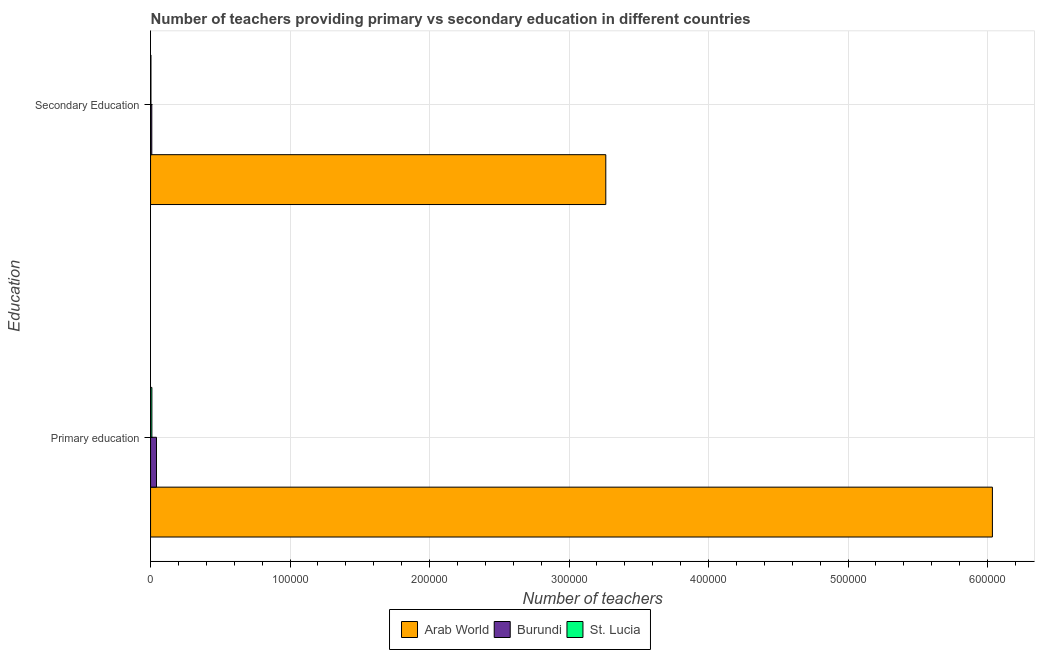How many different coloured bars are there?
Your answer should be very brief. 3. How many groups of bars are there?
Give a very brief answer. 2. Are the number of bars on each tick of the Y-axis equal?
Make the answer very short. Yes. How many bars are there on the 2nd tick from the bottom?
Provide a succinct answer. 3. What is the label of the 1st group of bars from the top?
Your answer should be very brief. Secondary Education. What is the number of primary teachers in Arab World?
Provide a succinct answer. 6.03e+05. Across all countries, what is the maximum number of secondary teachers?
Give a very brief answer. 3.26e+05. Across all countries, what is the minimum number of primary teachers?
Make the answer very short. 947. In which country was the number of primary teachers maximum?
Offer a very short reply. Arab World. In which country was the number of primary teachers minimum?
Offer a very short reply. St. Lucia. What is the total number of secondary teachers in the graph?
Ensure brevity in your answer.  3.27e+05. What is the difference between the number of primary teachers in Burundi and that in Arab World?
Your answer should be compact. -5.99e+05. What is the difference between the number of secondary teachers in Burundi and the number of primary teachers in Arab World?
Your response must be concise. -6.03e+05. What is the average number of primary teachers per country?
Offer a very short reply. 2.03e+05. What is the difference between the number of secondary teachers and number of primary teachers in Burundi?
Your answer should be very brief. -3368. What is the ratio of the number of secondary teachers in Arab World to that in St. Lucia?
Give a very brief answer. 1173.83. What does the 3rd bar from the top in Primary education represents?
Your answer should be compact. Arab World. What does the 1st bar from the bottom in Secondary Education represents?
Your answer should be very brief. Arab World. Are all the bars in the graph horizontal?
Ensure brevity in your answer.  Yes. What is the difference between two consecutive major ticks on the X-axis?
Your answer should be compact. 1.00e+05. Where does the legend appear in the graph?
Offer a terse response. Bottom center. How many legend labels are there?
Ensure brevity in your answer.  3. How are the legend labels stacked?
Your answer should be compact. Horizontal. What is the title of the graph?
Make the answer very short. Number of teachers providing primary vs secondary education in different countries. What is the label or title of the X-axis?
Your response must be concise. Number of teachers. What is the label or title of the Y-axis?
Make the answer very short. Education. What is the Number of teachers of Arab World in Primary education?
Offer a very short reply. 6.03e+05. What is the Number of teachers in Burundi in Primary education?
Offer a very short reply. 4245. What is the Number of teachers in St. Lucia in Primary education?
Make the answer very short. 947. What is the Number of teachers in Arab World in Secondary Education?
Your response must be concise. 3.26e+05. What is the Number of teachers in Burundi in Secondary Education?
Your answer should be very brief. 877. What is the Number of teachers of St. Lucia in Secondary Education?
Your answer should be compact. 278. Across all Education, what is the maximum Number of teachers in Arab World?
Keep it short and to the point. 6.03e+05. Across all Education, what is the maximum Number of teachers in Burundi?
Make the answer very short. 4245. Across all Education, what is the maximum Number of teachers of St. Lucia?
Offer a very short reply. 947. Across all Education, what is the minimum Number of teachers of Arab World?
Ensure brevity in your answer.  3.26e+05. Across all Education, what is the minimum Number of teachers in Burundi?
Make the answer very short. 877. Across all Education, what is the minimum Number of teachers in St. Lucia?
Make the answer very short. 278. What is the total Number of teachers in Arab World in the graph?
Provide a succinct answer. 9.30e+05. What is the total Number of teachers in Burundi in the graph?
Offer a very short reply. 5122. What is the total Number of teachers of St. Lucia in the graph?
Provide a short and direct response. 1225. What is the difference between the Number of teachers of Arab World in Primary education and that in Secondary Education?
Offer a very short reply. 2.77e+05. What is the difference between the Number of teachers of Burundi in Primary education and that in Secondary Education?
Offer a terse response. 3368. What is the difference between the Number of teachers in St. Lucia in Primary education and that in Secondary Education?
Provide a short and direct response. 669. What is the difference between the Number of teachers of Arab World in Primary education and the Number of teachers of Burundi in Secondary Education?
Provide a short and direct response. 6.03e+05. What is the difference between the Number of teachers of Arab World in Primary education and the Number of teachers of St. Lucia in Secondary Education?
Your answer should be compact. 6.03e+05. What is the difference between the Number of teachers in Burundi in Primary education and the Number of teachers in St. Lucia in Secondary Education?
Keep it short and to the point. 3967. What is the average Number of teachers in Arab World per Education?
Ensure brevity in your answer.  4.65e+05. What is the average Number of teachers in Burundi per Education?
Your answer should be very brief. 2561. What is the average Number of teachers in St. Lucia per Education?
Your response must be concise. 612.5. What is the difference between the Number of teachers in Arab World and Number of teachers in Burundi in Primary education?
Keep it short and to the point. 5.99e+05. What is the difference between the Number of teachers of Arab World and Number of teachers of St. Lucia in Primary education?
Provide a succinct answer. 6.03e+05. What is the difference between the Number of teachers in Burundi and Number of teachers in St. Lucia in Primary education?
Keep it short and to the point. 3298. What is the difference between the Number of teachers in Arab World and Number of teachers in Burundi in Secondary Education?
Offer a very short reply. 3.25e+05. What is the difference between the Number of teachers in Arab World and Number of teachers in St. Lucia in Secondary Education?
Offer a terse response. 3.26e+05. What is the difference between the Number of teachers in Burundi and Number of teachers in St. Lucia in Secondary Education?
Provide a succinct answer. 599. What is the ratio of the Number of teachers of Arab World in Primary education to that in Secondary Education?
Make the answer very short. 1.85. What is the ratio of the Number of teachers in Burundi in Primary education to that in Secondary Education?
Offer a terse response. 4.84. What is the ratio of the Number of teachers of St. Lucia in Primary education to that in Secondary Education?
Offer a terse response. 3.41. What is the difference between the highest and the second highest Number of teachers of Arab World?
Ensure brevity in your answer.  2.77e+05. What is the difference between the highest and the second highest Number of teachers in Burundi?
Provide a short and direct response. 3368. What is the difference between the highest and the second highest Number of teachers in St. Lucia?
Provide a short and direct response. 669. What is the difference between the highest and the lowest Number of teachers of Arab World?
Offer a very short reply. 2.77e+05. What is the difference between the highest and the lowest Number of teachers in Burundi?
Your response must be concise. 3368. What is the difference between the highest and the lowest Number of teachers of St. Lucia?
Provide a short and direct response. 669. 